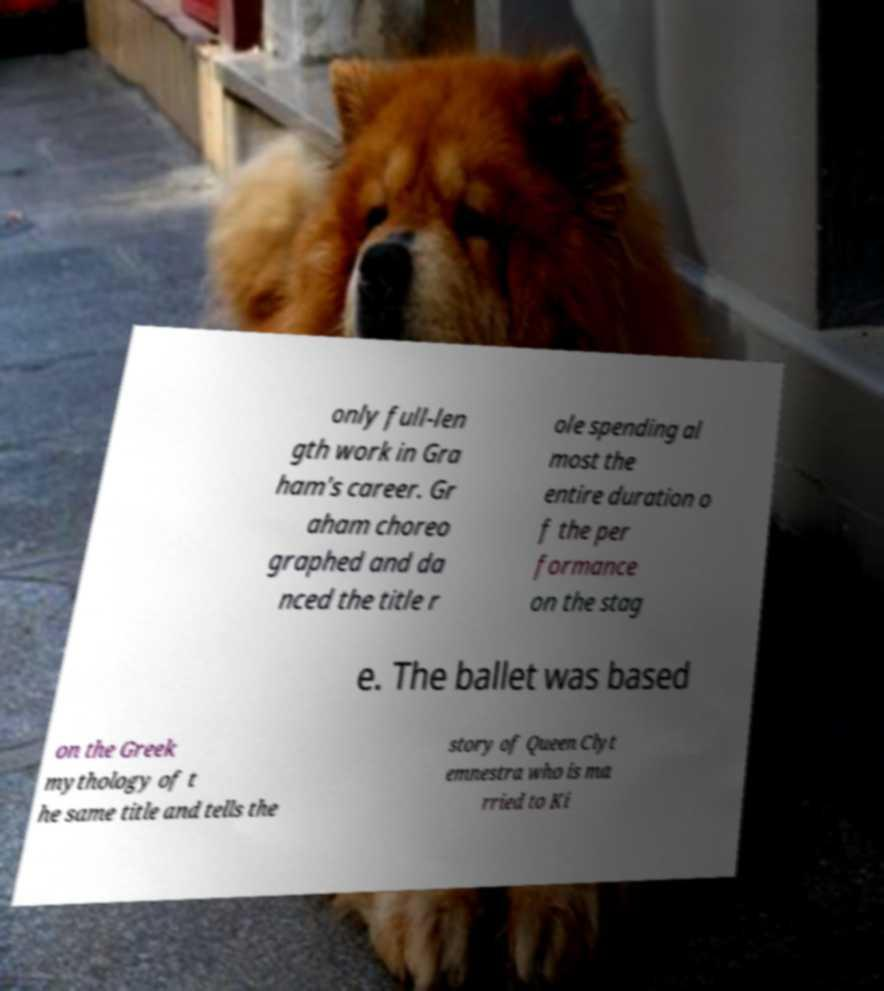Please identify and transcribe the text found in this image. only full-len gth work in Gra ham's career. Gr aham choreo graphed and da nced the title r ole spending al most the entire duration o f the per formance on the stag e. The ballet was based on the Greek mythology of t he same title and tells the story of Queen Clyt emnestra who is ma rried to Ki 